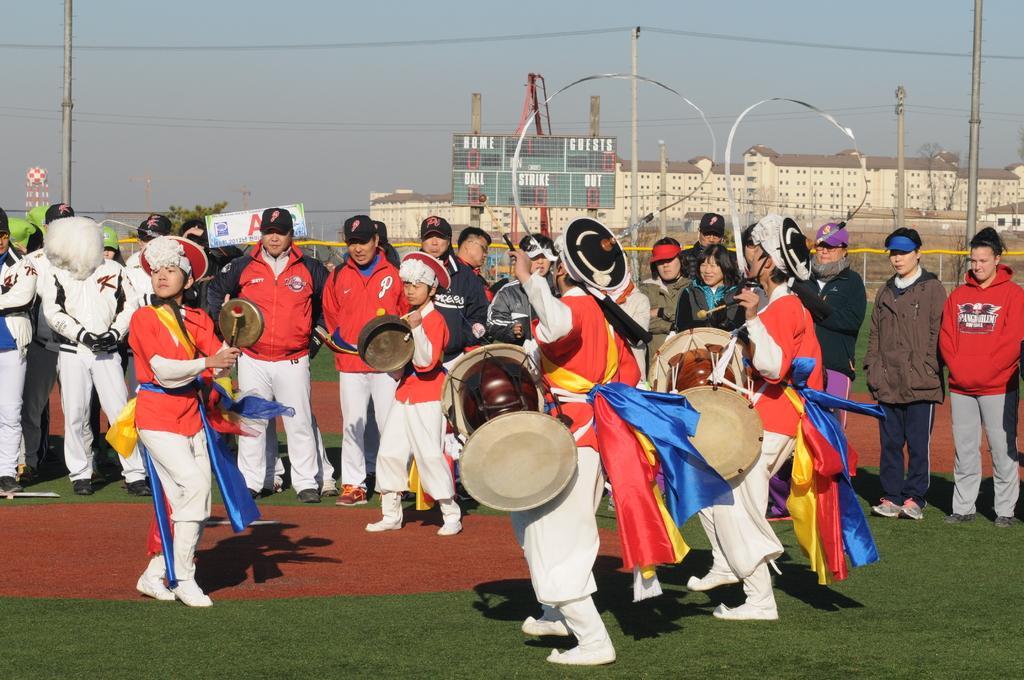Could you give a brief overview of what you see in this image? in this image there are few people. a parade is going on ,two people are holding drums in the front. behind them there are many people watching them. behind those people there are buildings 